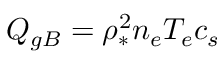Convert formula to latex. <formula><loc_0><loc_0><loc_500><loc_500>Q _ { g B } = \rho _ { * } ^ { 2 } n _ { e } T _ { e } c _ { s }</formula> 